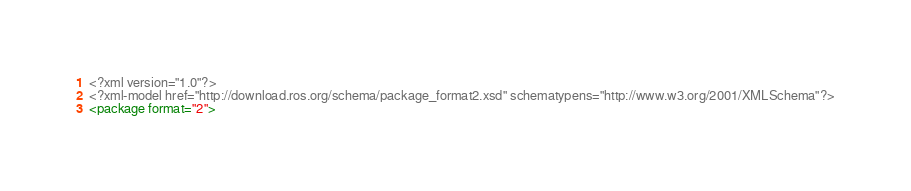Convert code to text. <code><loc_0><loc_0><loc_500><loc_500><_XML_><?xml version="1.0"?>
<?xml-model href="http://download.ros.org/schema/package_format2.xsd" schematypens="http://www.w3.org/2001/XMLSchema"?>
<package format="2"></code> 